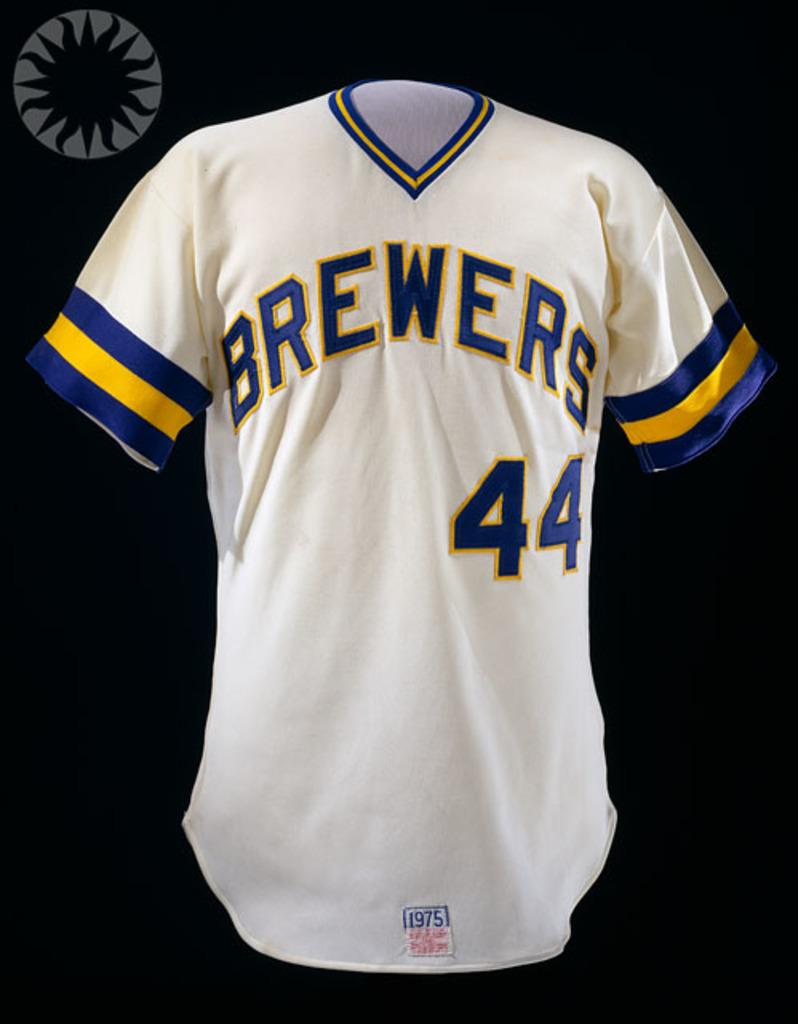Provide a one-sentence caption for the provided image. A blue and yellow striped white jersey displaying Brewers with the number forty-four on it. 